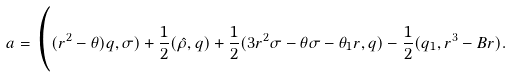<formula> <loc_0><loc_0><loc_500><loc_500>a = \Big ( ( r ^ { 2 } - \theta ) q , \sigma ) + \frac { 1 } { 2 } ( \hat { \rho } , q ) + \frac { 1 } { 2 } ( 3 r ^ { 2 } \sigma - \theta \sigma - \theta _ { 1 } r , q ) - \frac { 1 } { 2 } ( q _ { 1 } , r ^ { 3 } - B r ) .</formula> 